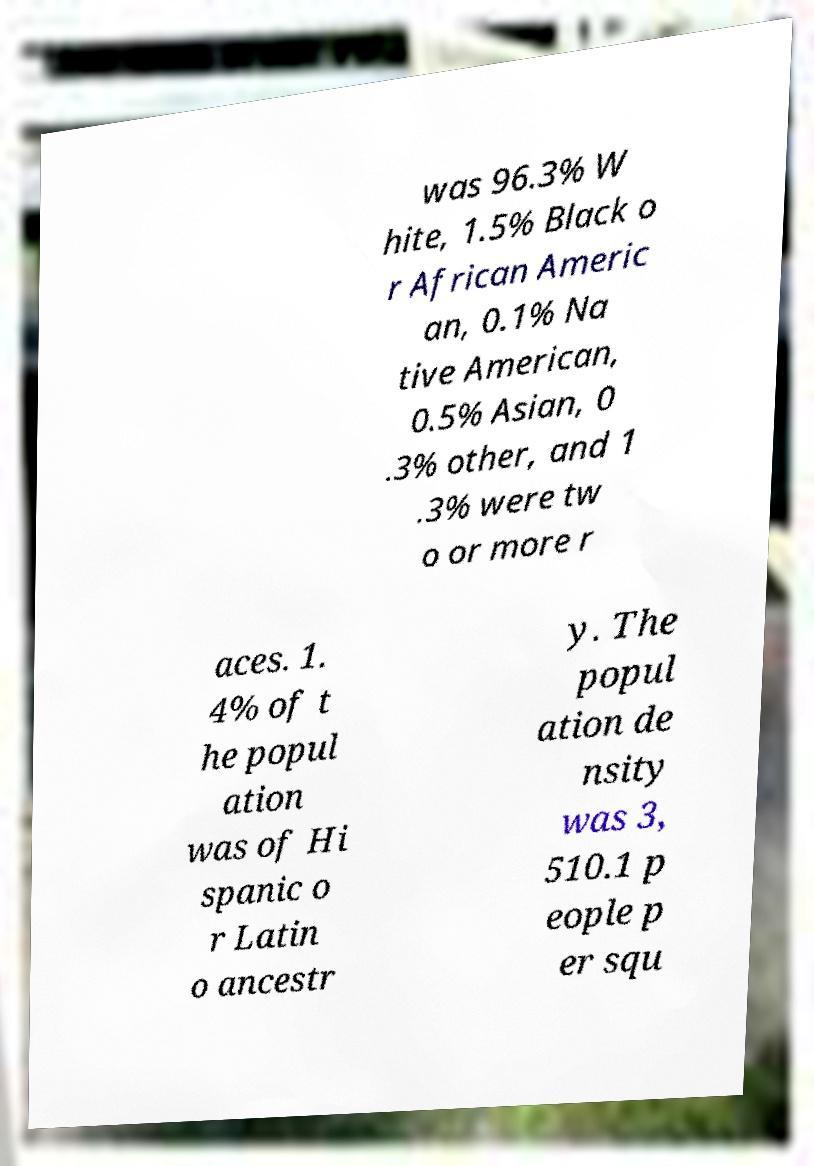Could you assist in decoding the text presented in this image and type it out clearly? was 96.3% W hite, 1.5% Black o r African Americ an, 0.1% Na tive American, 0.5% Asian, 0 .3% other, and 1 .3% were tw o or more r aces. 1. 4% of t he popul ation was of Hi spanic o r Latin o ancestr y. The popul ation de nsity was 3, 510.1 p eople p er squ 